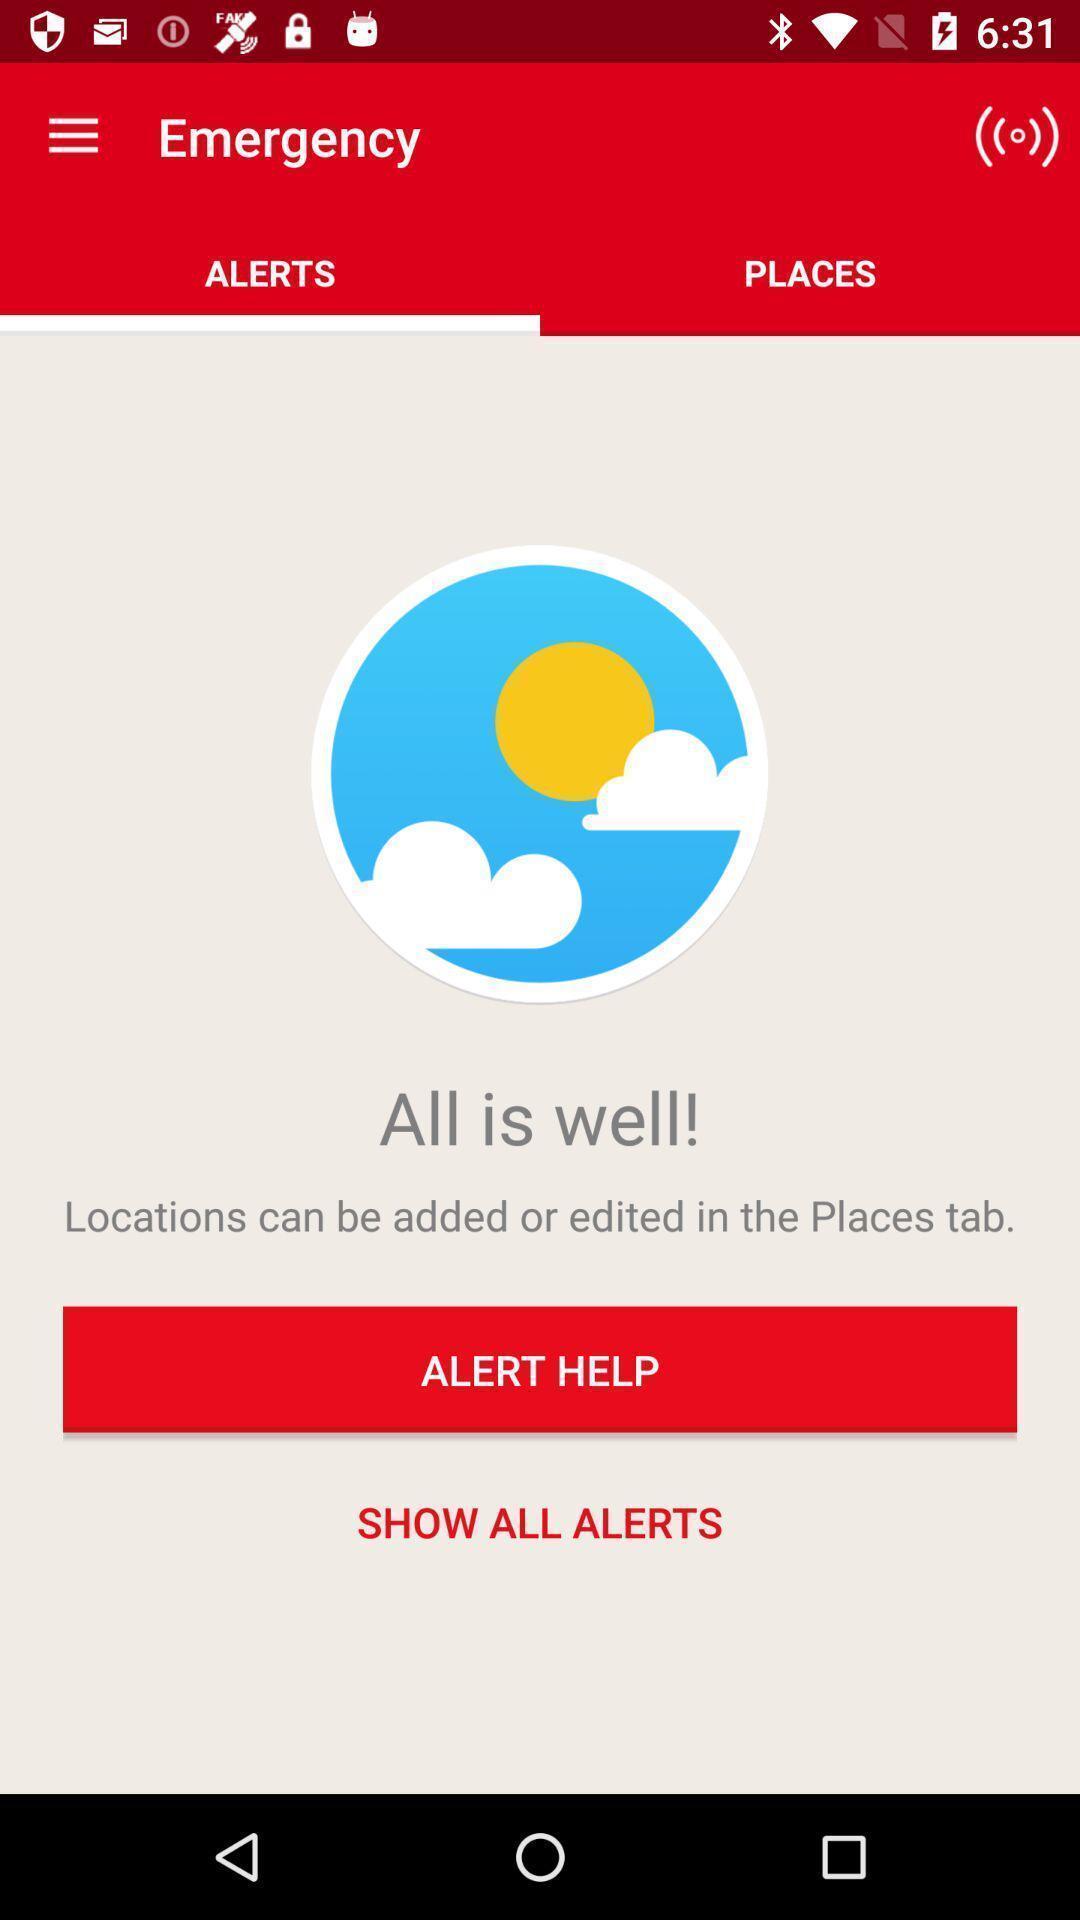Describe the key features of this screenshot. Page of an emergency assistance app. 